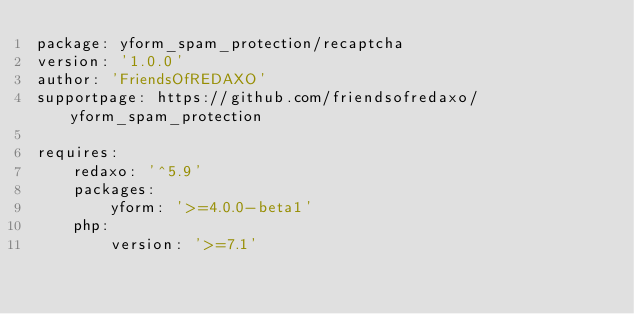Convert code to text. <code><loc_0><loc_0><loc_500><loc_500><_YAML_>package: yform_spam_protection/recaptcha
version: '1.0.0'
author: 'FriendsOfREDAXO'
supportpage: https://github.com/friendsofredaxo/yform_spam_protection

requires:
    redaxo: '^5.9'
    packages:
        yform: '>=4.0.0-beta1'
    php:
        version: '>=7.1'
</code> 